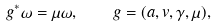Convert formula to latex. <formula><loc_0><loc_0><loc_500><loc_500>g ^ { * } \omega = \mu \omega , \quad g = ( a , v , \gamma , \mu ) ,</formula> 